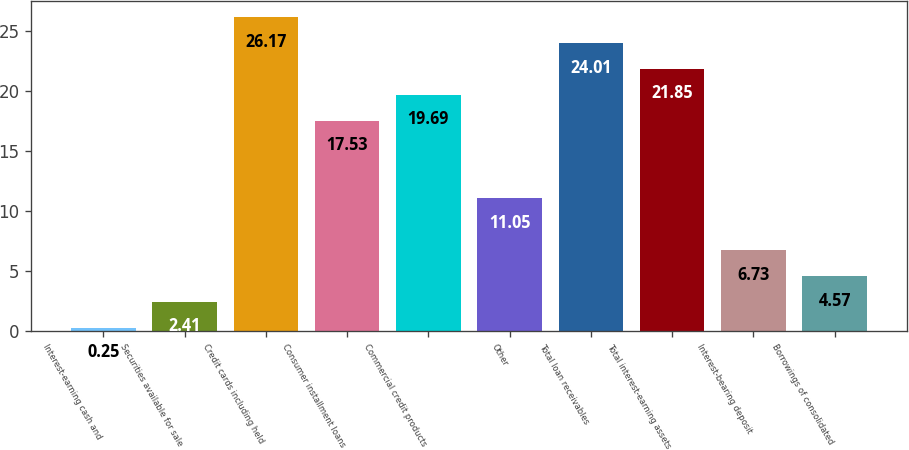Convert chart. <chart><loc_0><loc_0><loc_500><loc_500><bar_chart><fcel>Interest-earning cash and<fcel>Securities available for sale<fcel>Credit cards including held<fcel>Consumer installment loans<fcel>Commercial credit products<fcel>Other<fcel>Total loan receivables<fcel>Total interest-earning assets<fcel>Interest-bearing deposit<fcel>Borrowings of consolidated<nl><fcel>0.25<fcel>2.41<fcel>26.17<fcel>17.53<fcel>19.69<fcel>11.05<fcel>24.01<fcel>21.85<fcel>6.73<fcel>4.57<nl></chart> 